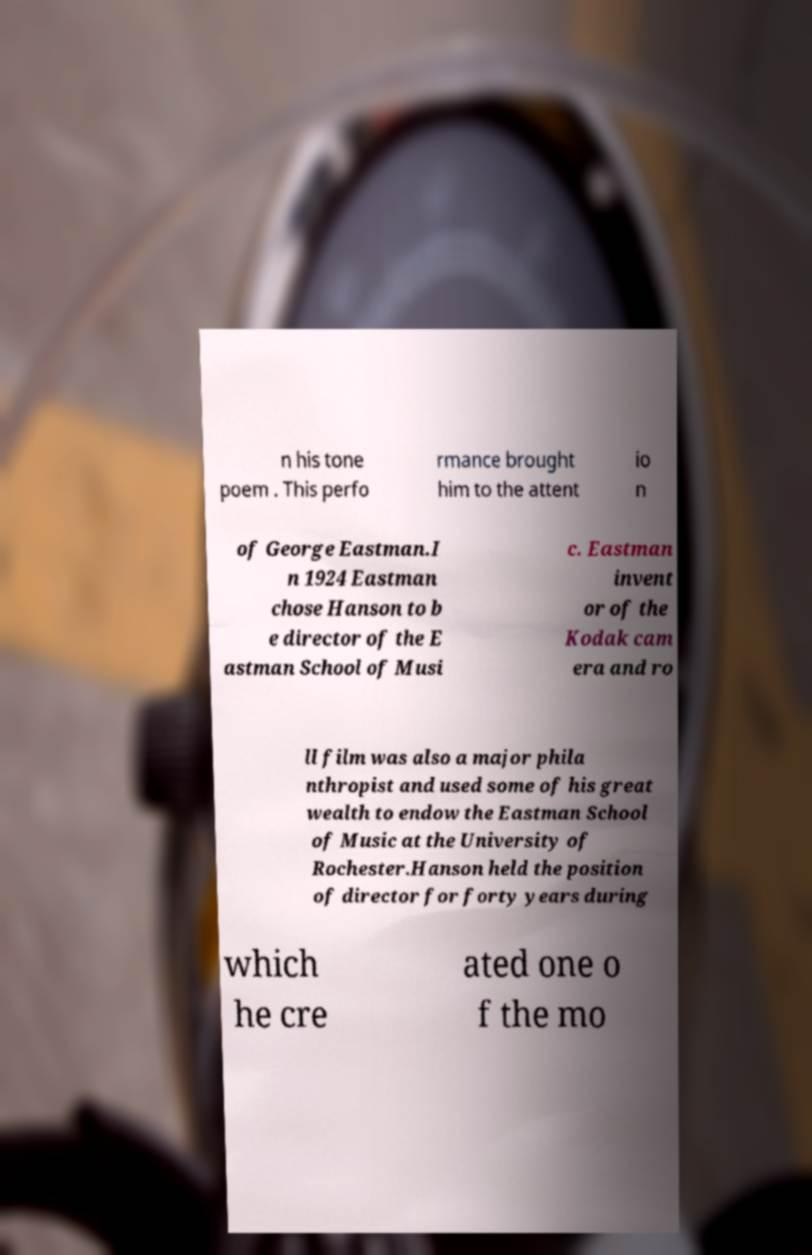What messages or text are displayed in this image? I need them in a readable, typed format. n his tone poem . This perfo rmance brought him to the attent io n of George Eastman.I n 1924 Eastman chose Hanson to b e director of the E astman School of Musi c. Eastman invent or of the Kodak cam era and ro ll film was also a major phila nthropist and used some of his great wealth to endow the Eastman School of Music at the University of Rochester.Hanson held the position of director for forty years during which he cre ated one o f the mo 